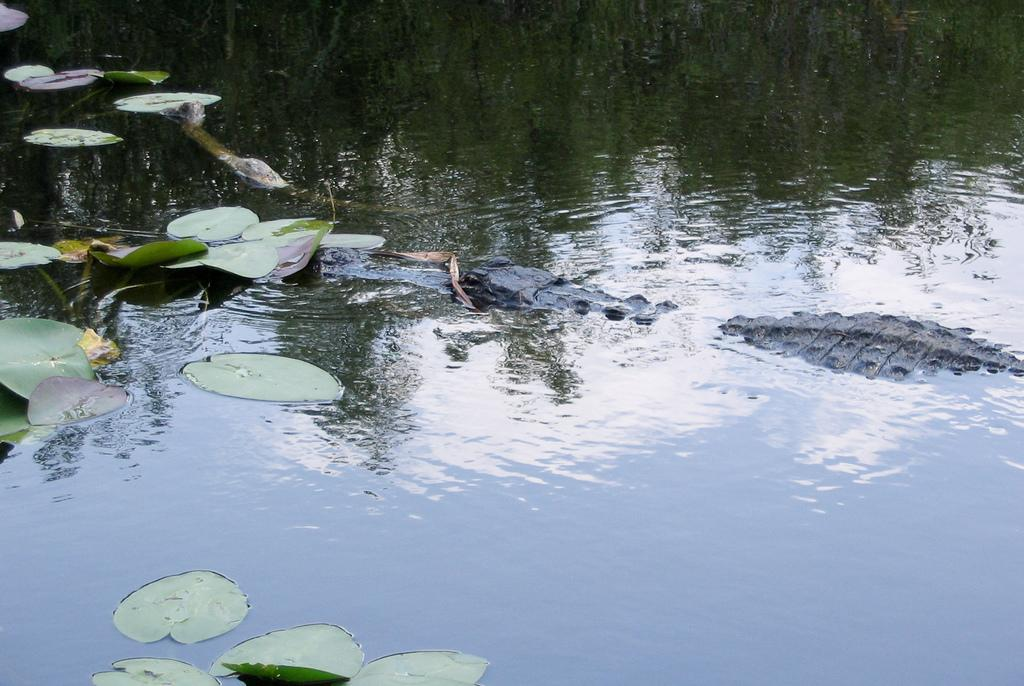What animal is the main subject of the image? There is a crocodile in the image. What is the crocodile doing in the image? The crocodile is swimming in the water. Where is the crocodile located in the image? The crocodile is in the middle of the image. What else can be seen floating on the water in the image? There are leaves floating on the water. On which side of the image are the leaves located? The leaves are on the left side of the image. What type of chin can be seen on the crocodile in the image? There is no chin visible on the crocodile in the image, as crocodiles do not have chins like humans. 